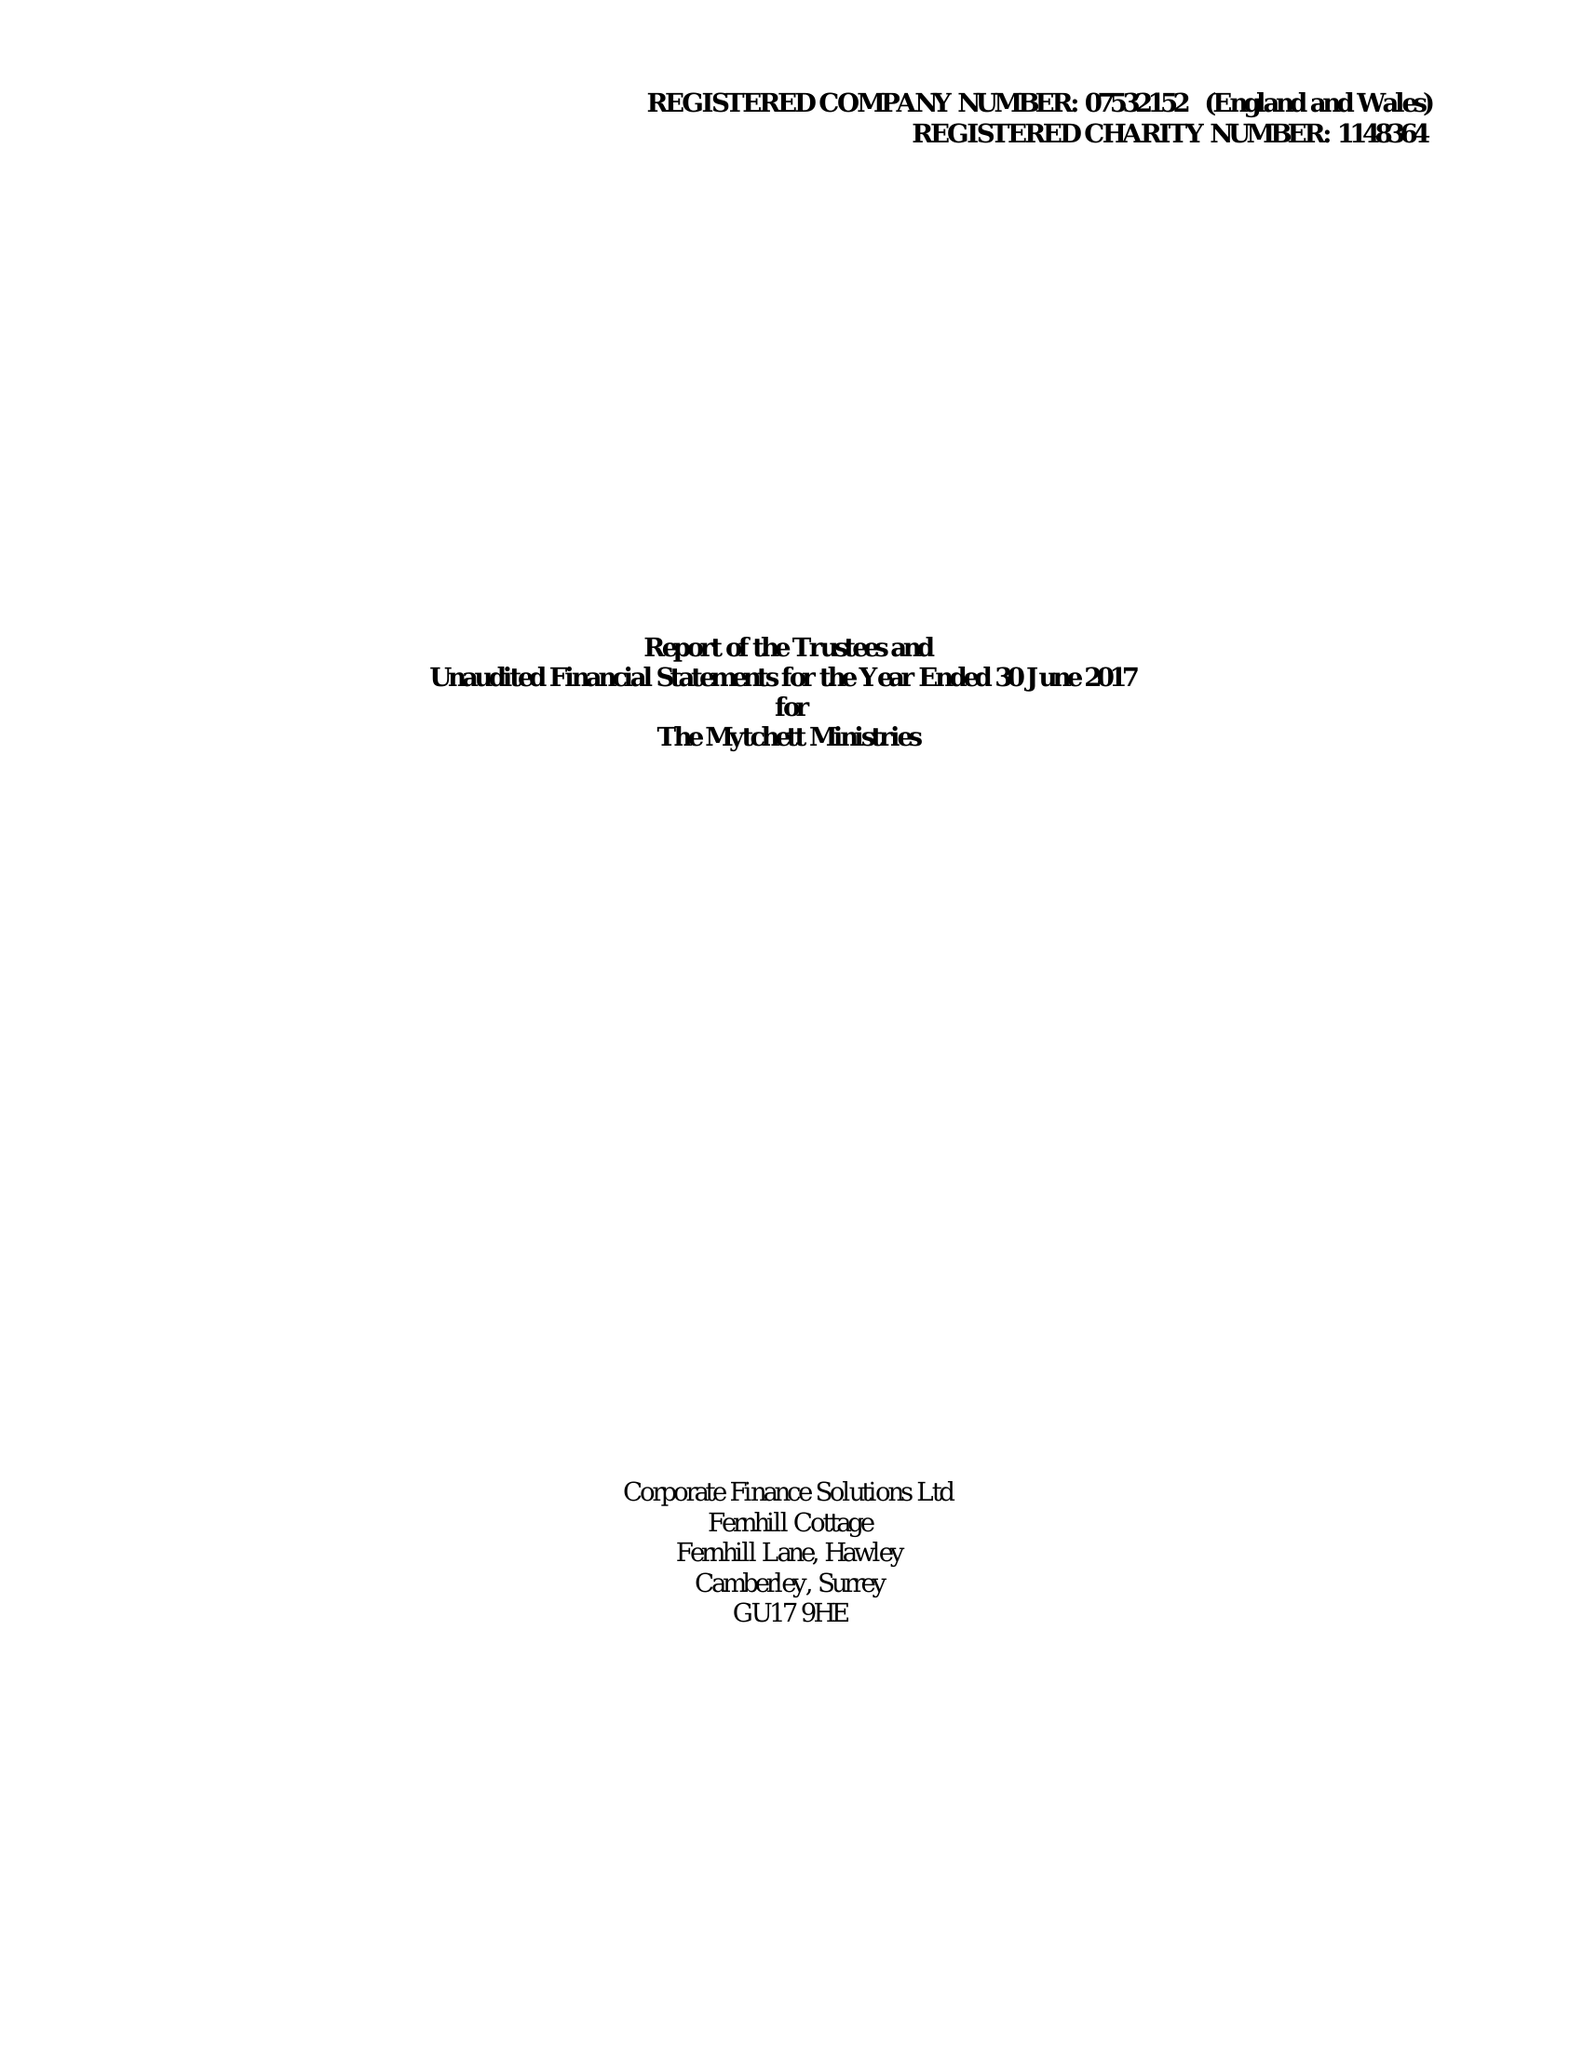What is the value for the address__post_town?
Answer the question using a single word or phrase. CAMBERLEY 